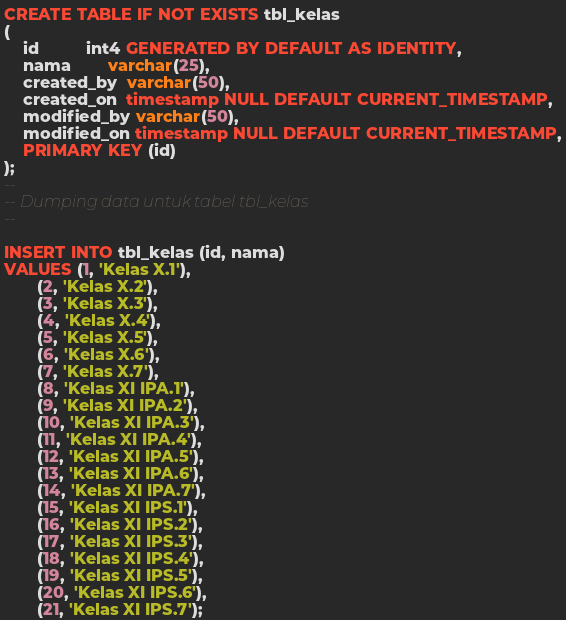Convert code to text. <code><loc_0><loc_0><loc_500><loc_500><_SQL_>CREATE TABLE IF NOT EXISTS tbl_kelas
(
    id          int4 GENERATED BY DEFAULT AS IDENTITY,
    nama        varchar(25),
    created_by  varchar(50),
    created_on  timestamp NULL DEFAULT CURRENT_TIMESTAMP,
    modified_by varchar(50),
    modified_on timestamp NULL DEFAULT CURRENT_TIMESTAMP,
    PRIMARY KEY (id)
);
--
-- Dumping data untuk tabel tbl_kelas
--

INSERT INTO tbl_kelas (id, nama)
VALUES (1, 'Kelas X.1'),
       (2, 'Kelas X.2'),
       (3, 'Kelas X.3'),
       (4, 'Kelas X.4'),
       (5, 'Kelas X.5'),
       (6, 'Kelas X.6'),
       (7, 'Kelas X.7'),
       (8, 'Kelas XI IPA.1'),
       (9, 'Kelas XI IPA.2'),
       (10, 'Kelas XI IPA.3'),
       (11, 'Kelas XI IPA.4'),
       (12, 'Kelas XI IPA.5'),
       (13, 'Kelas XI IPA.6'),
       (14, 'Kelas XI IPA.7'),
       (15, 'Kelas XI IPS.1'),
       (16, 'Kelas XI IPS.2'),
       (17, 'Kelas XI IPS.3'),
       (18, 'Kelas XI IPS.4'),
       (19, 'Kelas XI IPS.5'),
       (20, 'Kelas XI IPS.6'),
       (21, 'Kelas XI IPS.7');
</code> 